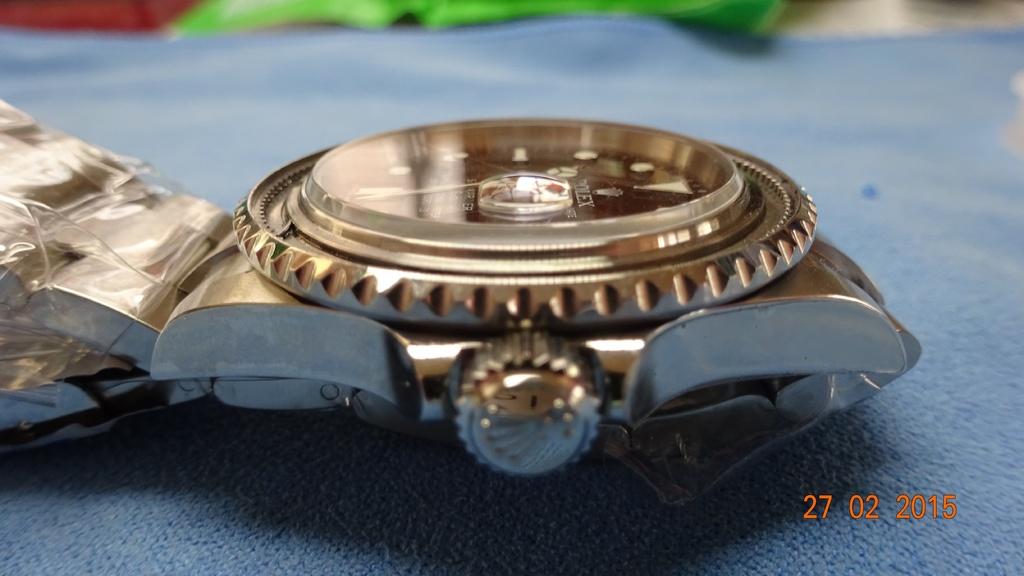What date was ths photo taken?
Give a very brief answer. 27 02 2015. What kind of watch is it?
Offer a terse response. Rolex. 